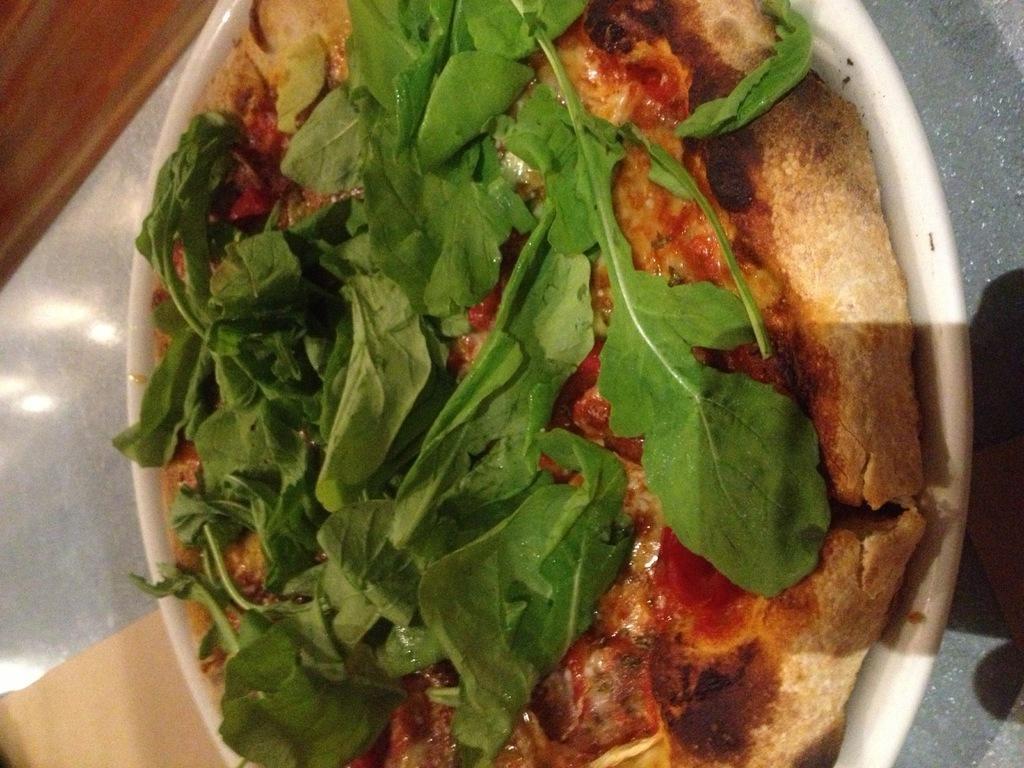How would you summarize this image in a sentence or two? In the image there is a pizza with leaves above it on a plate in front of the table. 